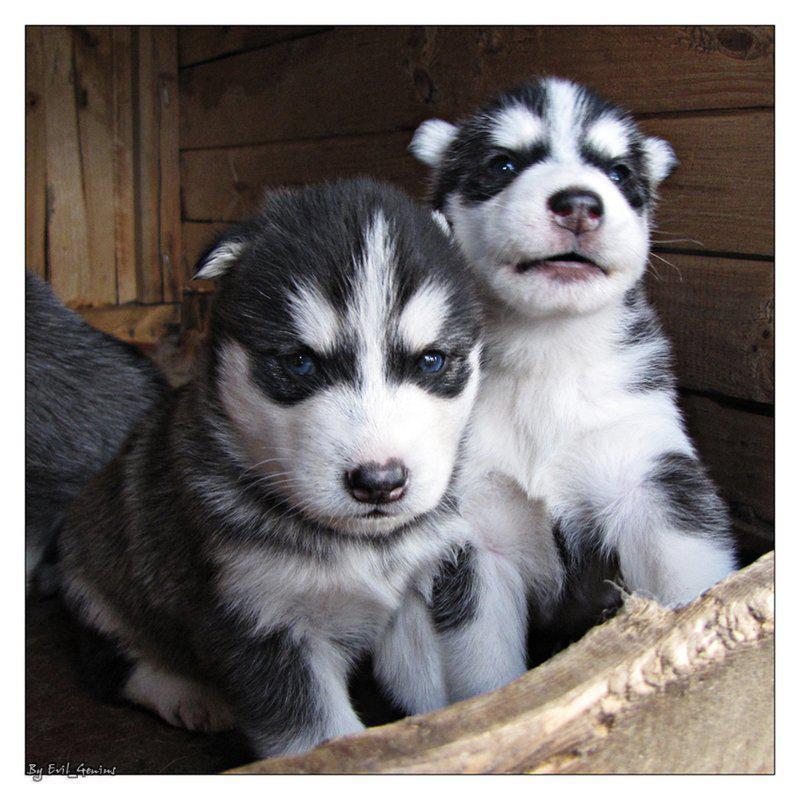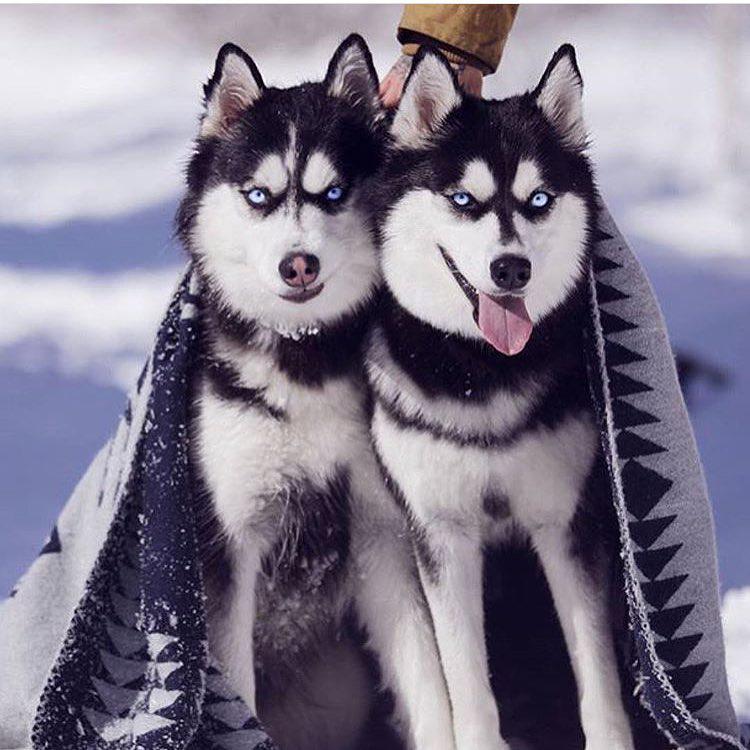The first image is the image on the left, the second image is the image on the right. Assess this claim about the two images: "At least one dog has blue eyes.". Correct or not? Answer yes or no. Yes. The first image is the image on the left, the second image is the image on the right. For the images displayed, is the sentence "At least one of the dogs is opening its mouth." factually correct? Answer yes or no. Yes. 